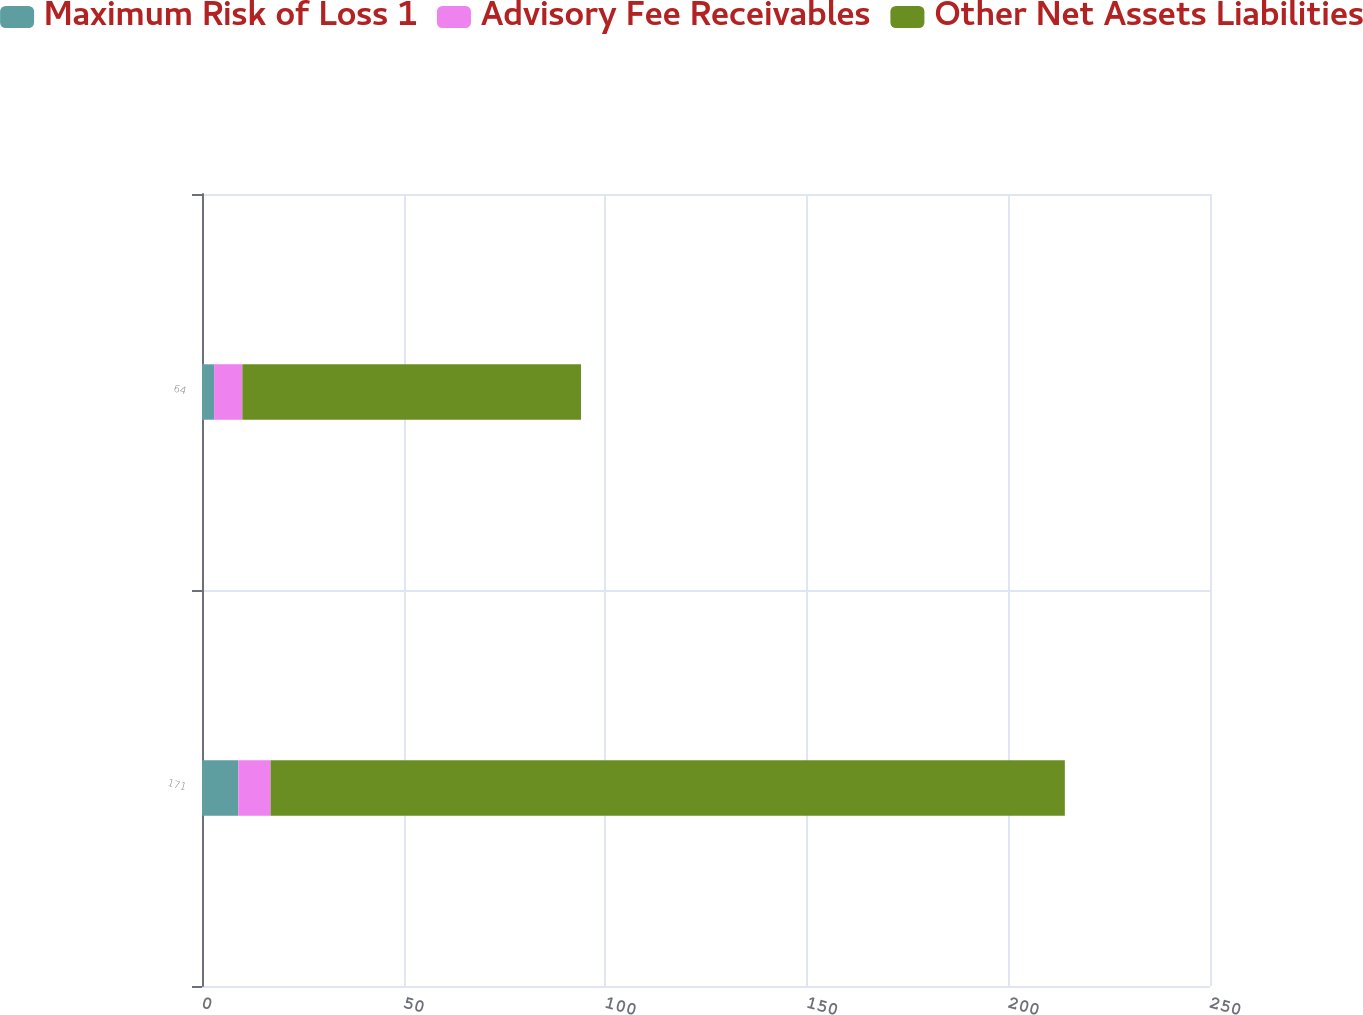Convert chart to OTSL. <chart><loc_0><loc_0><loc_500><loc_500><stacked_bar_chart><ecel><fcel>171<fcel>64<nl><fcel>Maximum Risk of Loss 1<fcel>9<fcel>3<nl><fcel>Advisory Fee Receivables<fcel>8<fcel>7<nl><fcel>Other Net Assets Liabilities<fcel>197<fcel>84<nl></chart> 